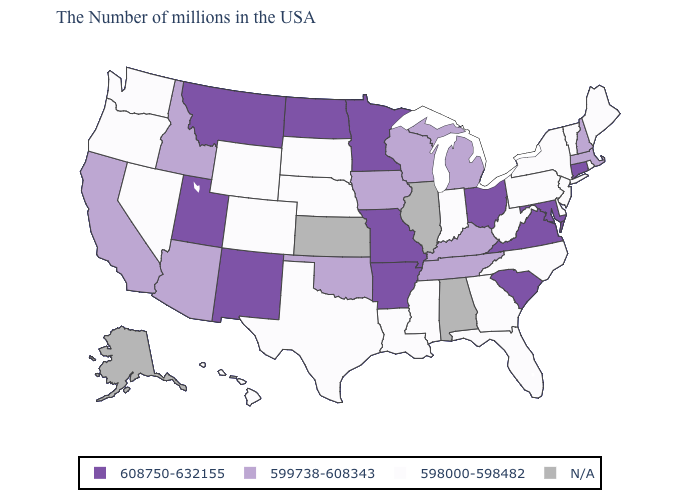What is the value of Kentucky?
Write a very short answer. 599738-608343. What is the value of Nebraska?
Keep it brief. 598000-598482. What is the value of Iowa?
Be succinct. 599738-608343. What is the highest value in the MidWest ?
Answer briefly. 608750-632155. What is the highest value in states that border Ohio?
Concise answer only. 599738-608343. Among the states that border Virginia , which have the highest value?
Write a very short answer. Maryland. Among the states that border Nebraska , does Missouri have the lowest value?
Be succinct. No. Name the states that have a value in the range 608750-632155?
Concise answer only. Connecticut, Maryland, Virginia, South Carolina, Ohio, Missouri, Arkansas, Minnesota, North Dakota, New Mexico, Utah, Montana. Does the first symbol in the legend represent the smallest category?
Write a very short answer. No. What is the value of Louisiana?
Be succinct. 598000-598482. Name the states that have a value in the range 608750-632155?
Give a very brief answer. Connecticut, Maryland, Virginia, South Carolina, Ohio, Missouri, Arkansas, Minnesota, North Dakota, New Mexico, Utah, Montana. Among the states that border Wisconsin , which have the lowest value?
Write a very short answer. Michigan, Iowa. Does the map have missing data?
Quick response, please. Yes. Name the states that have a value in the range N/A?
Keep it brief. Alabama, Illinois, Kansas, Alaska. 